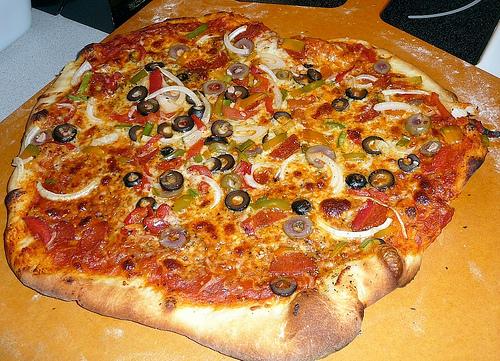Is the pizza burnt?
Quick response, please. No. What is the black topping on the pizza?
Give a very brief answer. Olives. Are there onions on this pizza?
Give a very brief answer. Yes. 